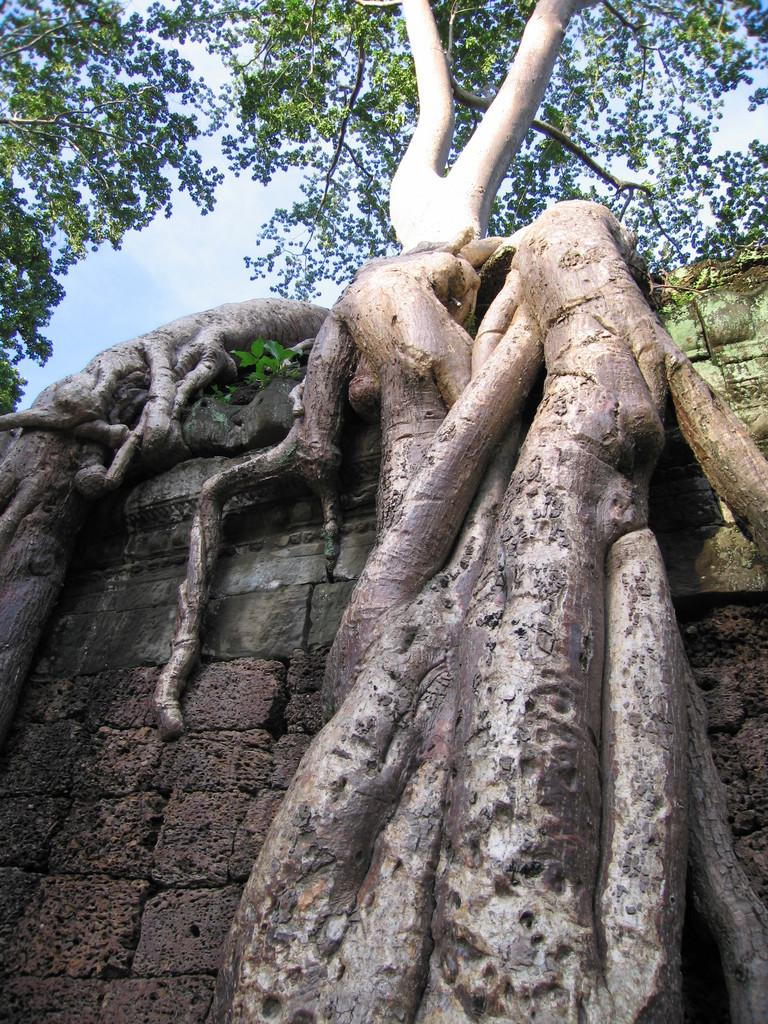What type of plant can be seen in the image? There is a tree in the image. What structure is visible in the image? There is a wall in the image. What can be seen in the background of the image? The sky is visible in the background of the image. What type of connection can be seen between the tree and the wall in the image? There is no visible connection between the tree and the wall in the image. What ideas might the image inspire for a garden design? The image itself does not provide enough information to inspire specific garden design ideas. 